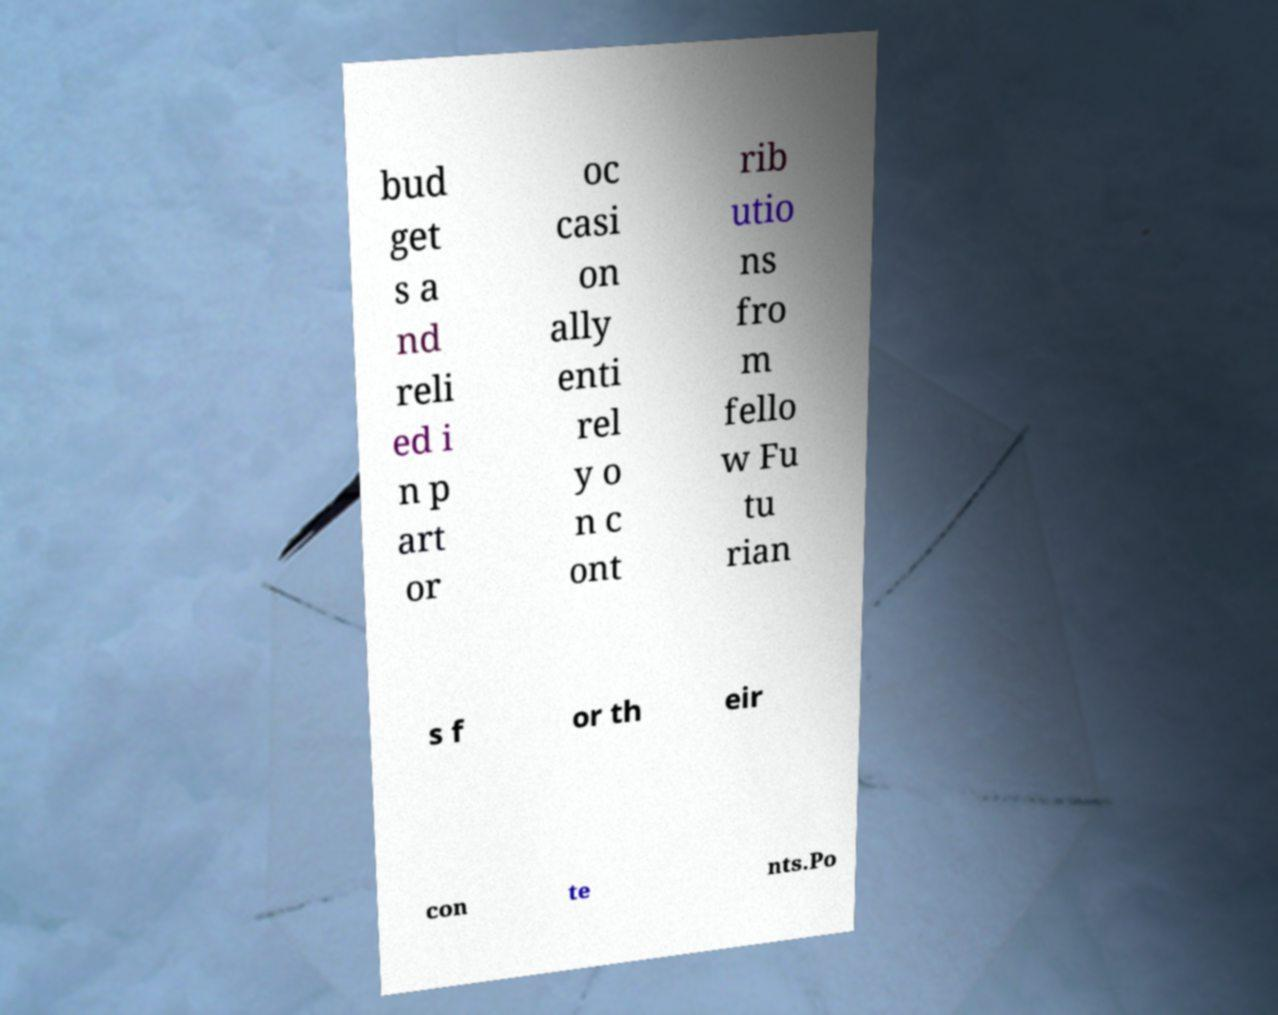There's text embedded in this image that I need extracted. Can you transcribe it verbatim? bud get s a nd reli ed i n p art or oc casi on ally enti rel y o n c ont rib utio ns fro m fello w Fu tu rian s f or th eir con te nts.Po 